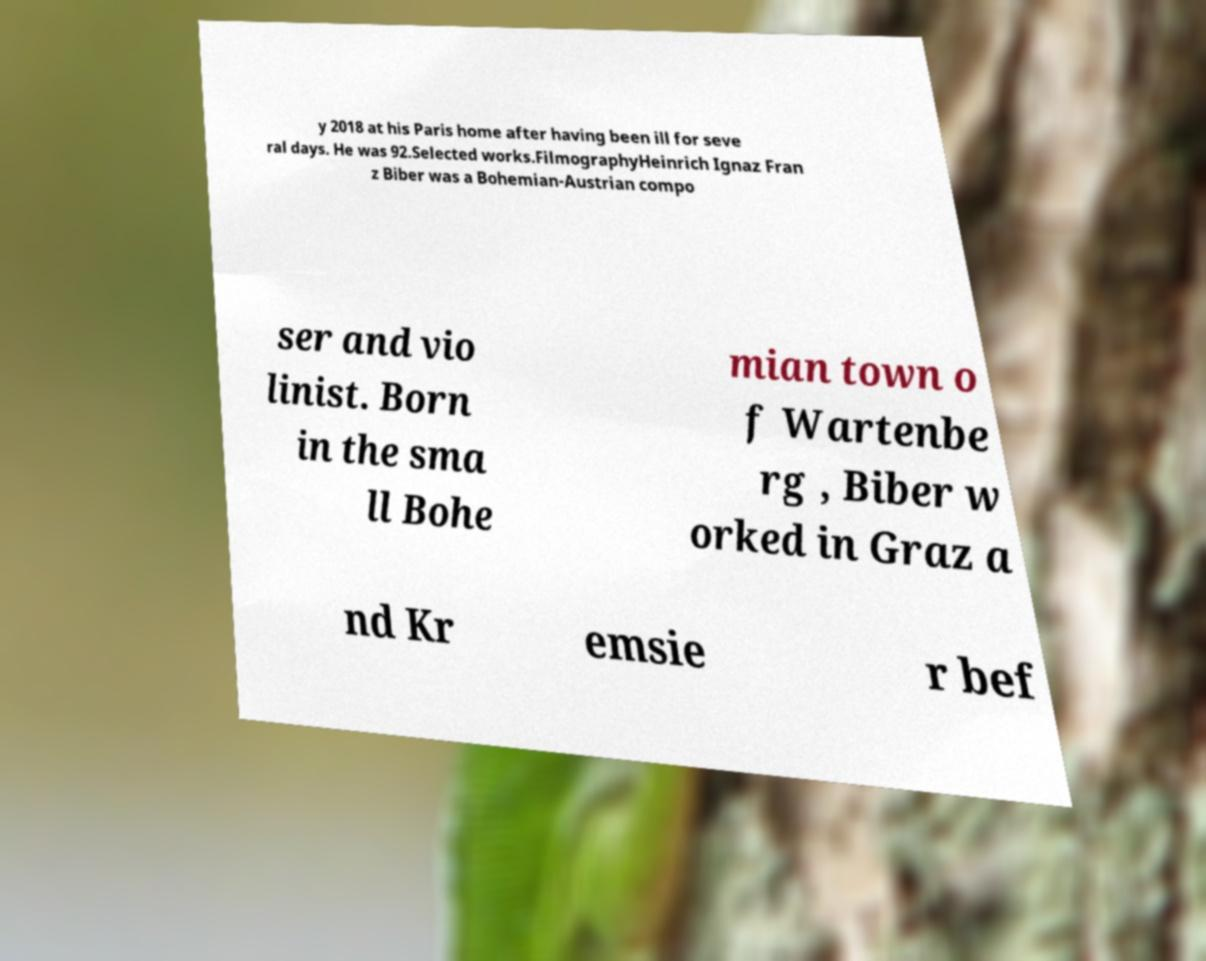Can you accurately transcribe the text from the provided image for me? y 2018 at his Paris home after having been ill for seve ral days. He was 92.Selected works.FilmographyHeinrich Ignaz Fran z Biber was a Bohemian-Austrian compo ser and vio linist. Born in the sma ll Bohe mian town o f Wartenbe rg , Biber w orked in Graz a nd Kr emsie r bef 